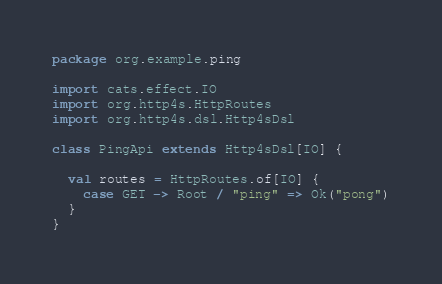<code> <loc_0><loc_0><loc_500><loc_500><_Scala_>package org.example.ping

import cats.effect.IO
import org.http4s.HttpRoutes
import org.http4s.dsl.Http4sDsl

class PingApi extends Http4sDsl[IO] {

  val routes = HttpRoutes.of[IO] {
    case GET -> Root / "ping" => Ok("pong")
  }
}
</code> 